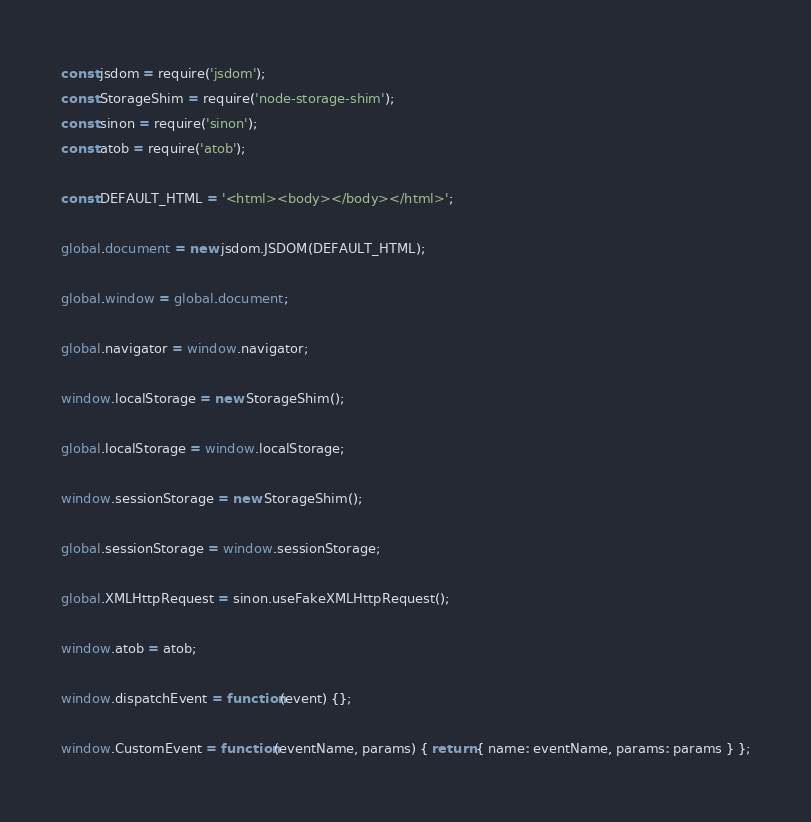<code> <loc_0><loc_0><loc_500><loc_500><_JavaScript_>const jsdom = require('jsdom');
const StorageShim = require('node-storage-shim');
const sinon = require('sinon');
const atob = require('atob');

const DEFAULT_HTML = '<html><body></body></html>';

global.document = new jsdom.JSDOM(DEFAULT_HTML);

global.window = global.document;

global.navigator = window.navigator;

window.localStorage = new StorageShim();

global.localStorage = window.localStorage;

window.sessionStorage = new StorageShim();

global.sessionStorage = window.sessionStorage;

global.XMLHttpRequest = sinon.useFakeXMLHttpRequest();

window.atob = atob;

window.dispatchEvent = function(event) {};

window.CustomEvent = function(eventName, params) { return { name: eventName, params: params } };
</code> 